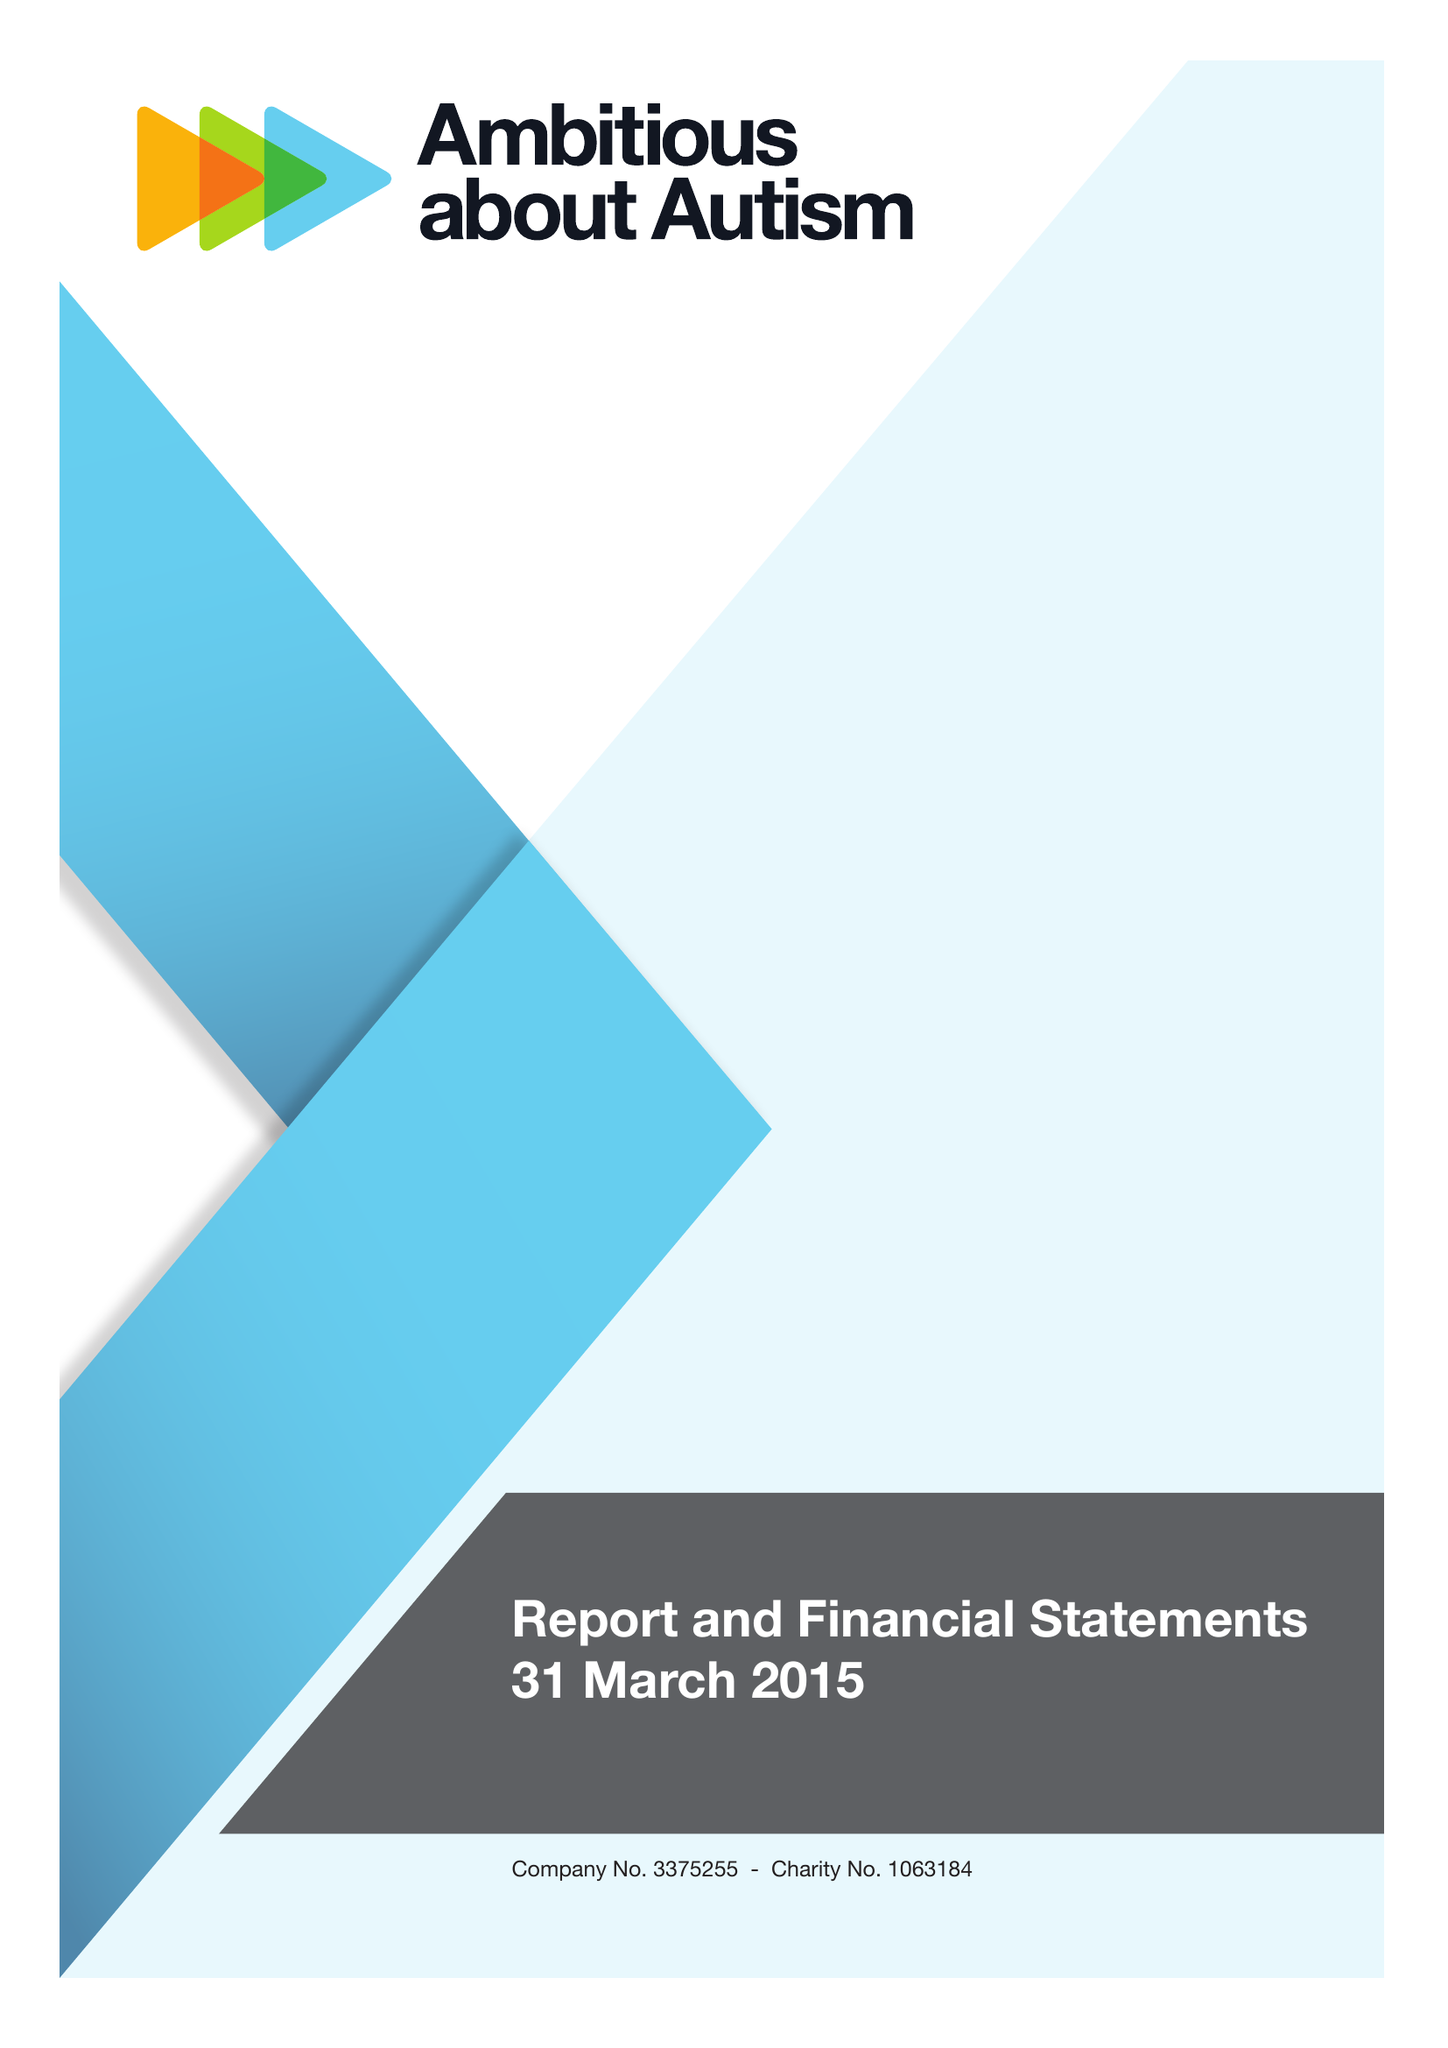What is the value for the address__post_town?
Answer the question using a single word or phrase. LONDON 